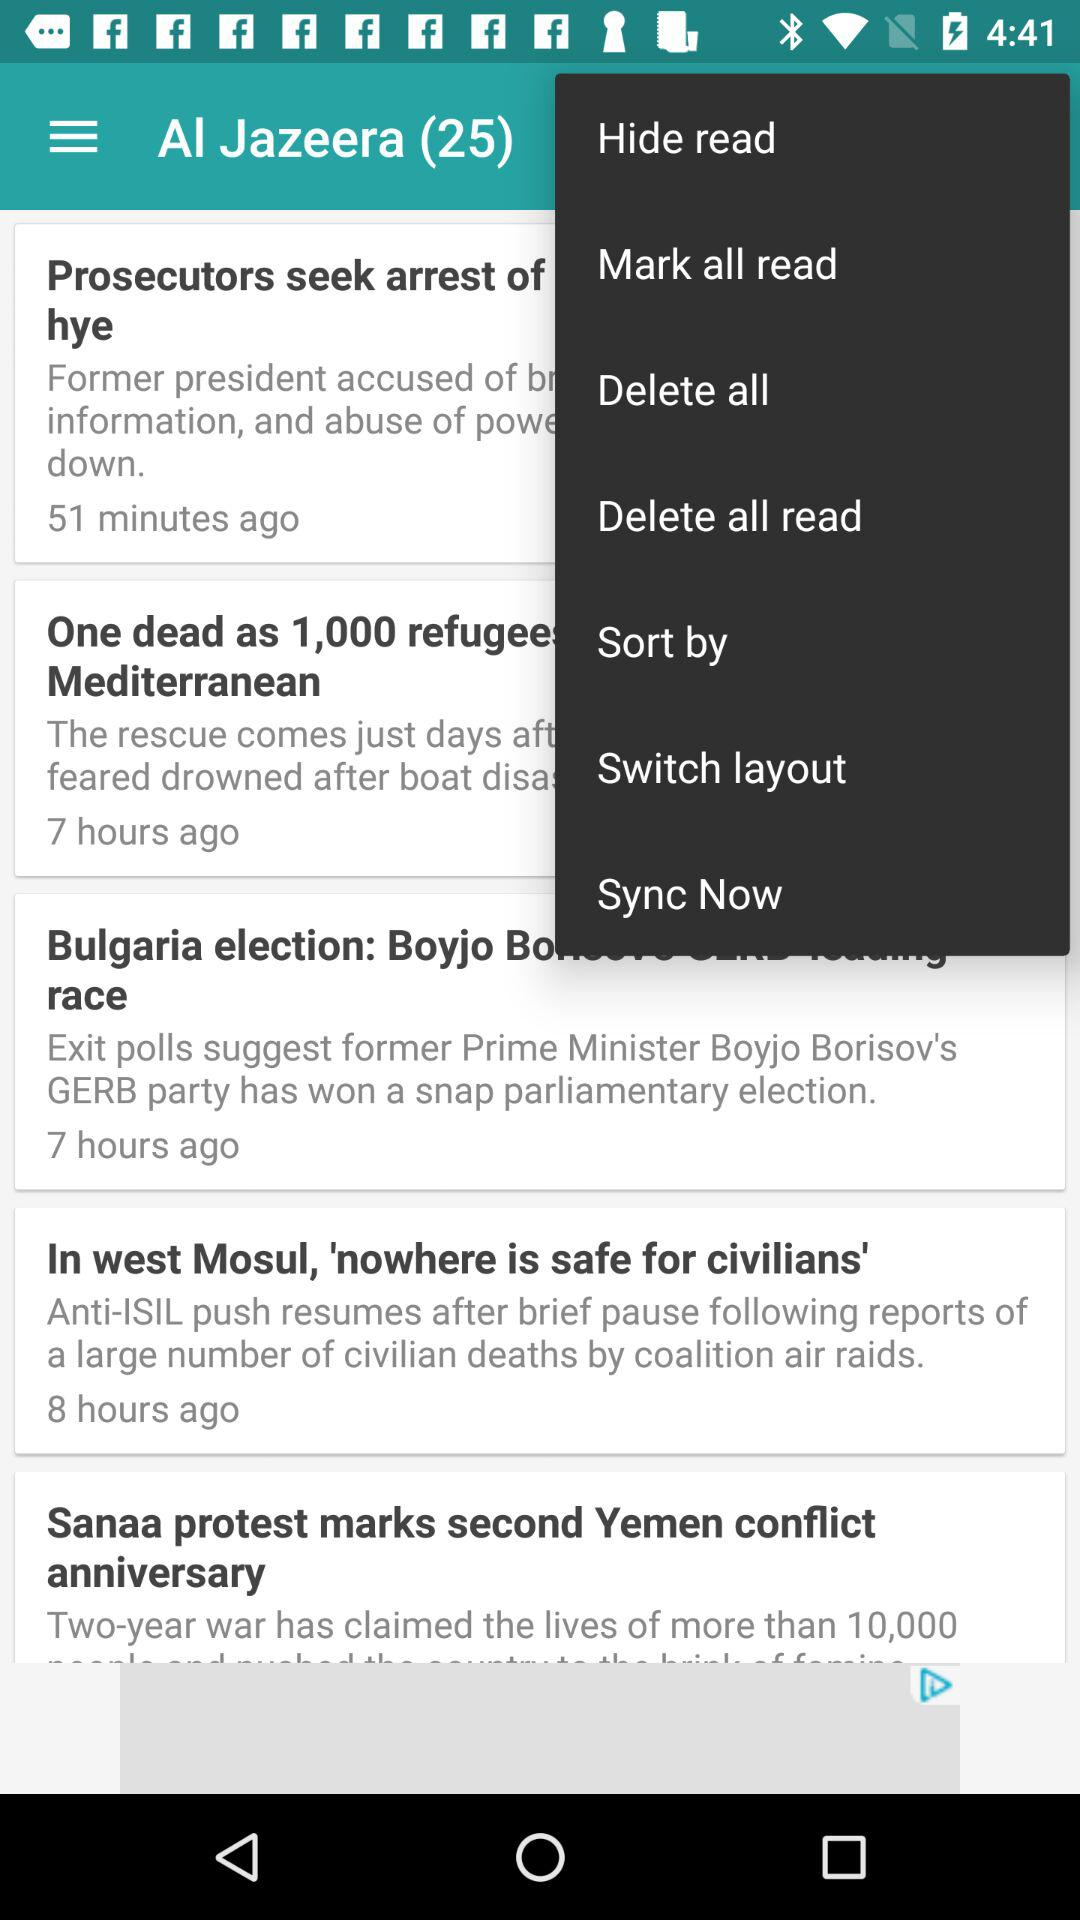How many hours ago was the news "In west Mosul, 'nowhere is safe for civilians'" published? The news was published 8 hours ago. 